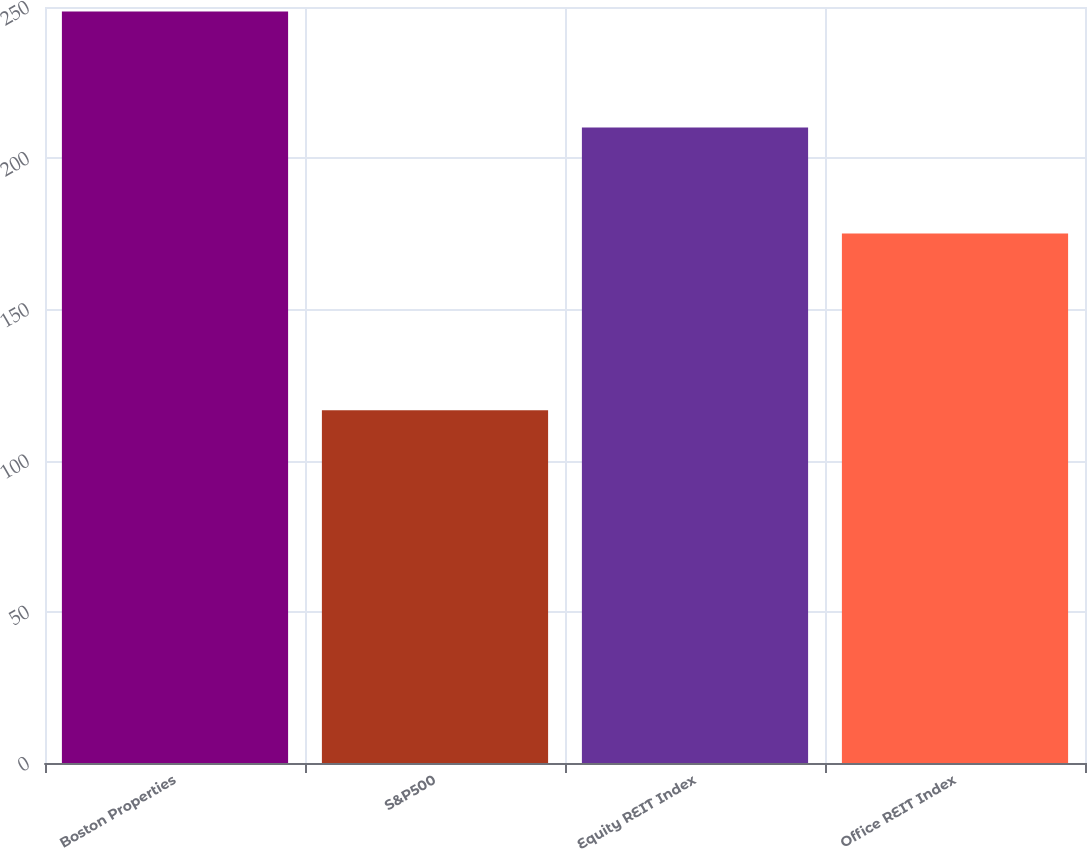Convert chart. <chart><loc_0><loc_0><loc_500><loc_500><bar_chart><fcel>Boston Properties<fcel>S&P500<fcel>Equity REIT Index<fcel>Office REIT Index<nl><fcel>248.48<fcel>116.61<fcel>210.12<fcel>175.11<nl></chart> 